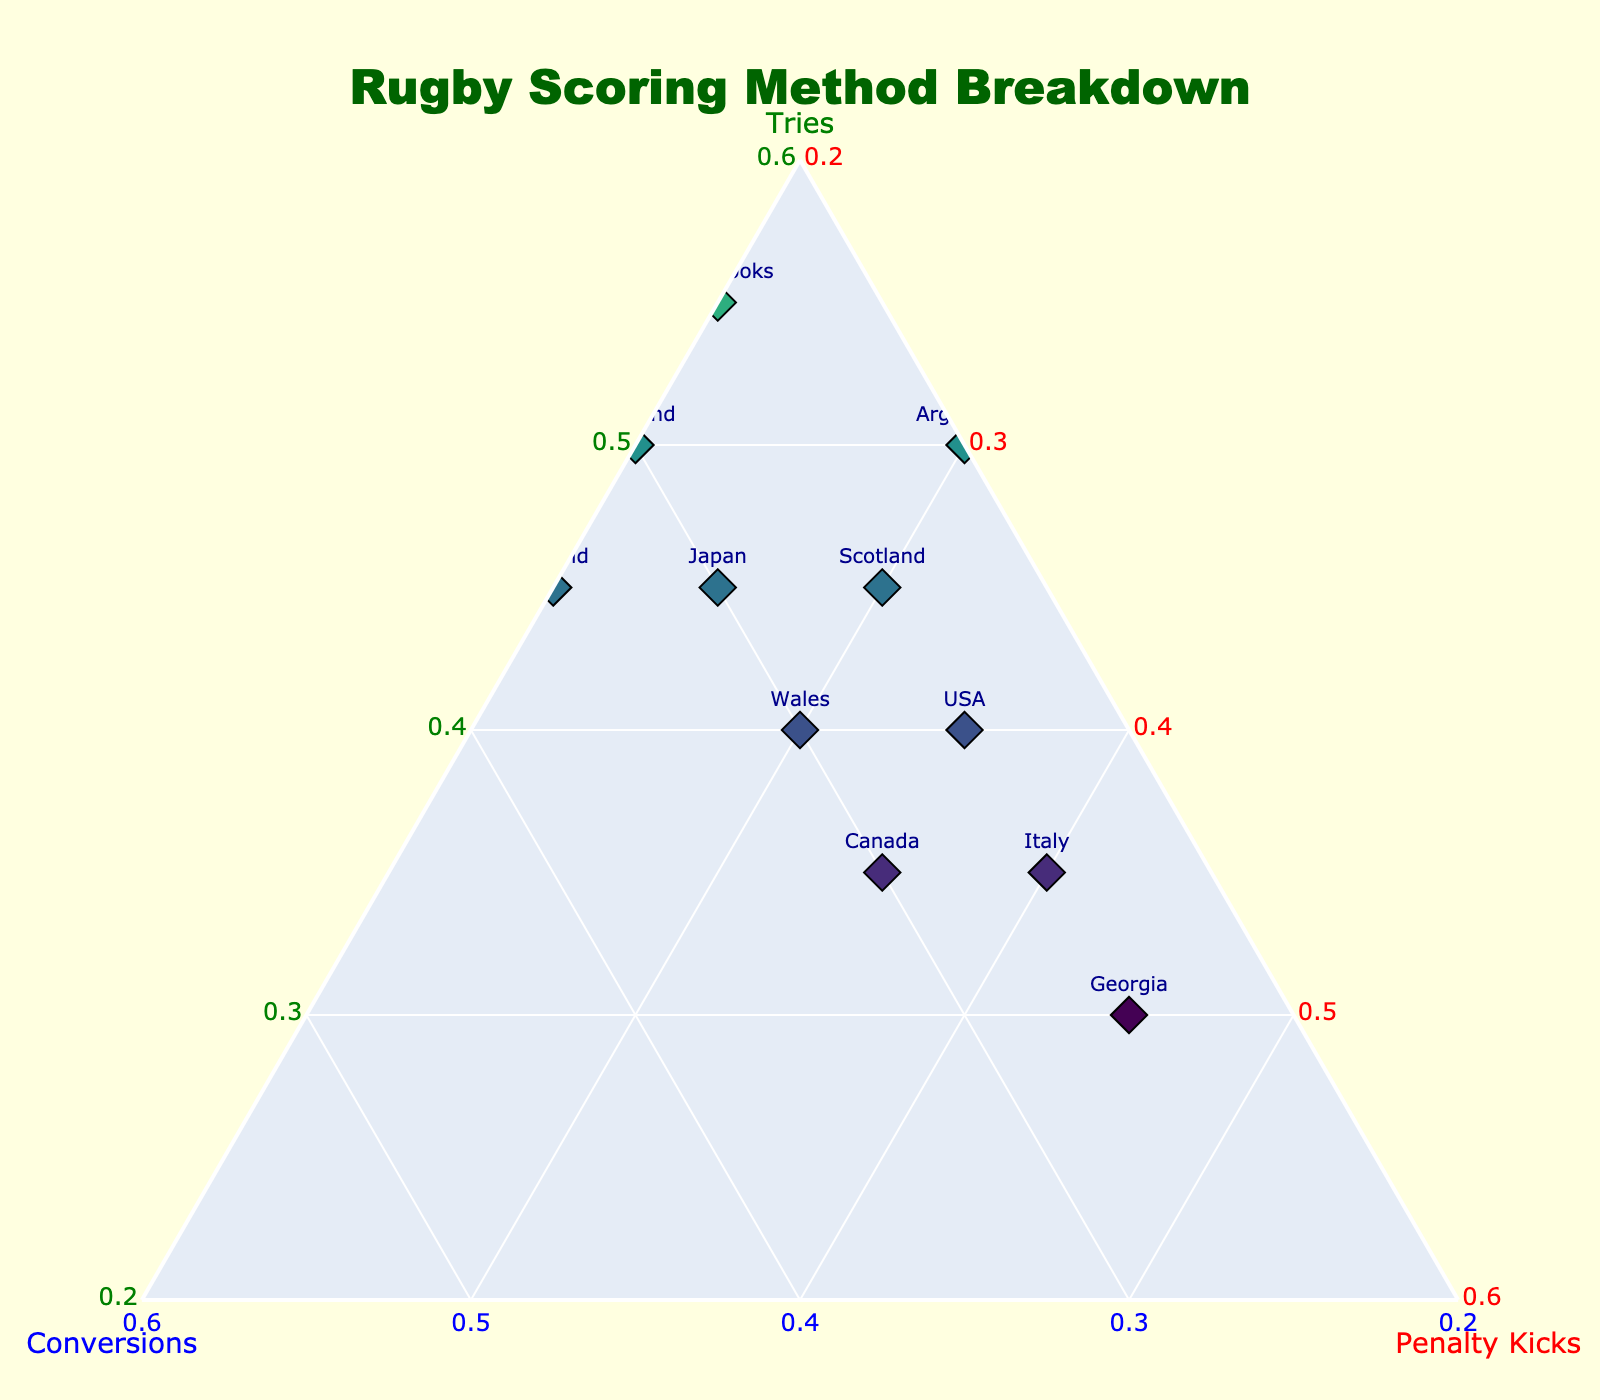Who scored the most tries? By looking at the plot, the team with the highest proportion of tries is the one closest to the 'Tries' axis. Fiji is the furthest from the other axes, indicating its high proportion of tries.
Answer: Fiji Which team scored the highest percentage of penalty kicks? In a ternary plot, the team with the highest percentage of penalty kicks will be closest to the 'Penalty Kicks' axis. Georgia is the closest to the 'Penalty Kicks' axis.
Answer: Georgia Which two teams have an approximately equal split between tries, conversions, and penalty kicks? Look for teams that are positioned near the center of the plot, as this indicates a balanced distribution among the three scoring methods. USA and Canada are positioned near the center.
Answer: USA and Canada How does England's scoring method distribution compare to Ireland's? Check the positions of England and Ireland related to the axes. England is closer to the 'Penalty Kicks' axis while Ireland is closer to the 'Conversions' axis, indicating that Ireland has more conversions.
Answer: England has more penalty kicks, Ireland has more conversions What is the dominant scoring method for Japan? Locate Japan on the plot and identify which axis it is closest to. Japan is closer to the 'Conversions' axis, indicating conversions as their dominant scoring method.
Answer: Conversions Which team is least dependent on penalty kicks for scoring? Find the team that is the farthest from the 'Penalty Kicks' axis. Fiji is farthest away from the 'Penalty Kicks' axis.
Answer: Fiji Which team has an equal proportion of tries and penalty kicks but fewer conversions? Look for a team on the diagonal line from 'Tries' to 'Penalty Kicks', but lower towards the 'Conversions' axis. France appears to have an equal proportion of tries and penalty kicks with fewer conversions.
Answer: France Is there any team that has scored more tries than the All Blacks but fewer conversions? Compare the positions of all other teams with that of the All Blacks. Wallabies and Fiji have more tries than the All Blacks, but Wallabies have fewer conversions.
Answer: Wallabies 